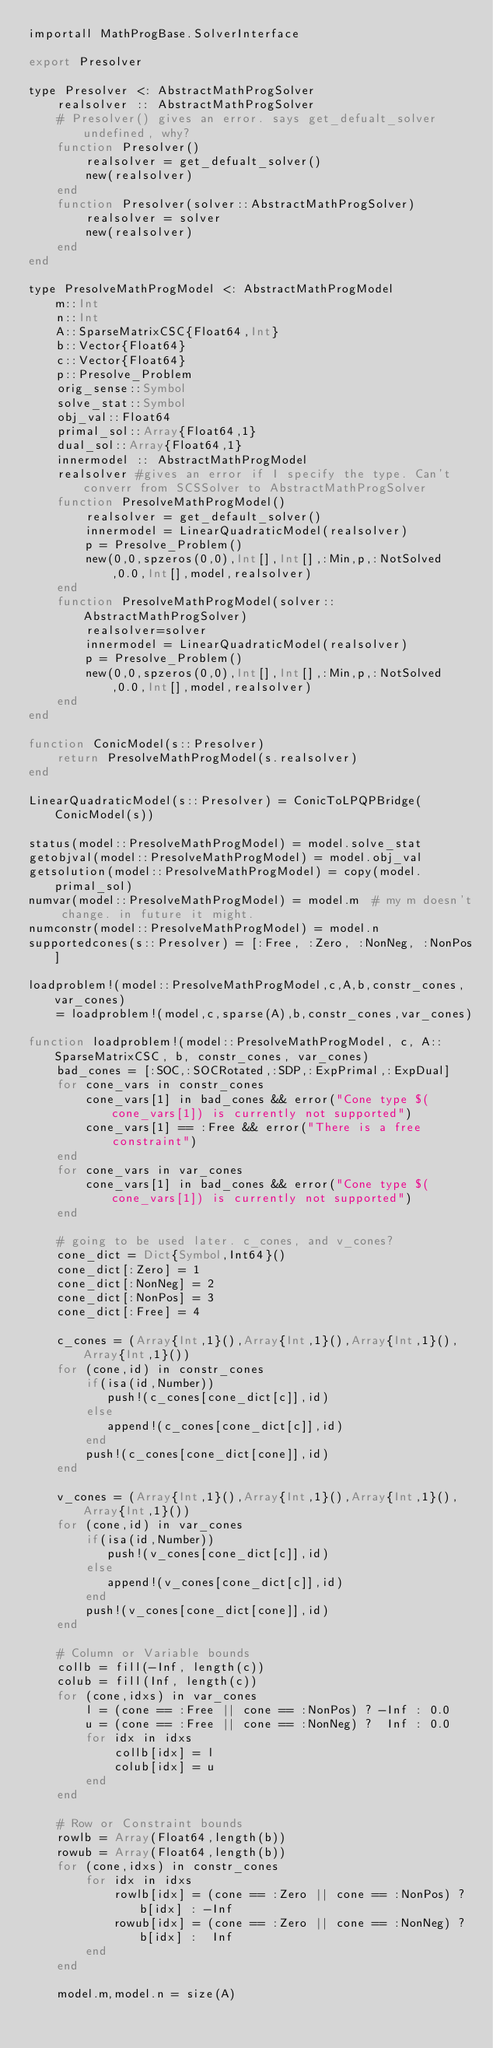<code> <loc_0><loc_0><loc_500><loc_500><_Julia_>importall MathProgBase.SolverInterface

export Presolver

type Presolver <: AbstractMathProgSolver
    realsolver :: AbstractMathProgSolver
    # Presolver() gives an error. says get_defualt_solver undefined, why?
    function Presolver()
        realsolver = get_defualt_solver()
        new(realsolver)
    end
    function Presolver(solver::AbstractMathProgSolver)
        realsolver = solver
        new(realsolver)
    end
end

type PresolveMathProgModel <: AbstractMathProgModel
    m::Int
    n::Int
    A::SparseMatrixCSC{Float64,Int}
    b::Vector{Float64}
    c::Vector{Float64}
    p::Presolve_Problem
    orig_sense::Symbol
    solve_stat::Symbol
    obj_val::Float64
    primal_sol::Array{Float64,1}
    dual_sol::Array{Float64,1}
    innermodel :: AbstractMathProgModel
    realsolver #gives an error if I specify the type. Can't converr from SCSSolver to AbstractMathProgSolver
    function PresolveMathProgModel()
        realsolver = get_default_solver()
        innermodel = LinearQuadraticModel(realsolver)
        p = Presolve_Problem()
        new(0,0,spzeros(0,0),Int[],Int[],:Min,p,:NotSolved,0.0,Int[],model,realsolver)
    end
    function PresolveMathProgModel(solver::AbstractMathProgSolver)
        realsolver=solver
        innermodel = LinearQuadraticModel(realsolver)
        p = Presolve_Problem()
        new(0,0,spzeros(0,0),Int[],Int[],:Min,p,:NotSolved,0.0,Int[],model,realsolver)
    end
end

function ConicModel(s::Presolver)
    return PresolveMathProgModel(s.realsolver)
end

LinearQuadraticModel(s::Presolver) = ConicToLPQPBridge(ConicModel(s))

status(model::PresolveMathProgModel) = model.solve_stat
getobjval(model::PresolveMathProgModel) = model.obj_val
getsolution(model::PresolveMathProgModel) = copy(model.primal_sol)
numvar(model::PresolveMathProgModel) = model.m  # my m doesn't change. in future it might.
numconstr(model::PresolveMathProgModel) = model.n
supportedcones(s::Presolver) = [:Free, :Zero, :NonNeg, :NonPos]

loadproblem!(model::PresolveMathProgModel,c,A,b,constr_cones,var_cones)
    = loadproblem!(model,c,sparse(A),b,constr_cones,var_cones)

function loadproblem!(model::PresolveMathProgModel, c, A::SparseMatrixCSC, b, constr_cones, var_cones)
    bad_cones = [:SOC,:SOCRotated,:SDP,:ExpPrimal,:ExpDual]
    for cone_vars in constr_cones
        cone_vars[1] in bad_cones && error("Cone type $(cone_vars[1]) is currently not supported")
        cone_vars[1] == :Free && error("There is a free constraint")
    end
    for cone_vars in var_cones
        cone_vars[1] in bad_cones && error("Cone type $(cone_vars[1]) is currently not supported")
    end

    # going to be used later. c_cones, and v_cones?
    cone_dict = Dict{Symbol,Int64}()
    cone_dict[:Zero] = 1
    cone_dict[:NonNeg] = 2
    cone_dict[:NonPos] = 3
    cone_dict[:Free] = 4

    c_cones = (Array{Int,1}(),Array{Int,1}(),Array{Int,1}(),Array{Int,1}())
    for (cone,id) in constr_cones
        if(isa(id,Number))
           push!(c_cones[cone_dict[c]],id)
        else
           append!(c_cones[cone_dict[c]],id)
        end
        push!(c_cones[cone_dict[cone]],id)
    end

    v_cones = (Array{Int,1}(),Array{Int,1}(),Array{Int,1}(),Array{Int,1}())
    for (cone,id) in var_cones
        if(isa(id,Number))
           push!(v_cones[cone_dict[c]],id)
        else
           append!(v_cones[cone_dict[c]],id)
        end
        push!(v_cones[cone_dict[cone]],id)
    end

    # Column or Variable bounds
    collb = fill(-Inf, length(c))
    colub = fill(Inf, length(c))
    for (cone,idxs) in var_cones
        l = (cone == :Free || cone == :NonPos) ? -Inf : 0.0
        u = (cone == :Free || cone == :NonNeg) ?  Inf : 0.0
        for idx in idxs
            collb[idx] = l
            colub[idx] = u
        end
    end

    # Row or Constraint bounds
    rowlb = Array(Float64,length(b))
    rowub = Array(Float64,length(b))
    for (cone,idxs) in constr_cones
        for idx in idxs
            rowlb[idx] = (cone == :Zero || cone == :NonPos) ? b[idx] : -Inf
            rowub[idx] = (cone == :Zero || cone == :NonNeg) ? b[idx] :  Inf
        end
    end

    model.m,model.n = size(A)</code> 